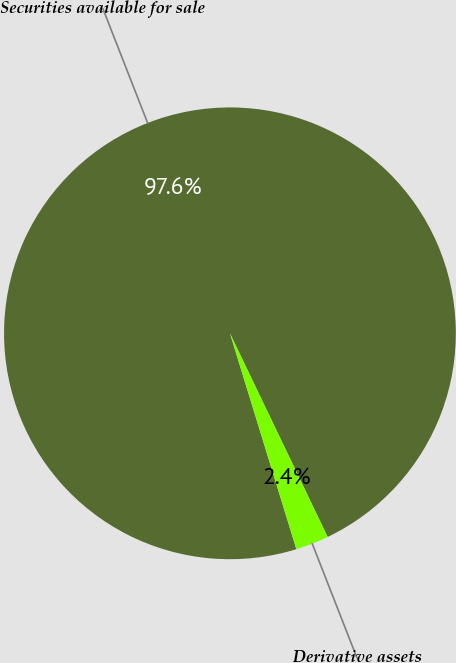Convert chart. <chart><loc_0><loc_0><loc_500><loc_500><pie_chart><fcel>Securities available for sale<fcel>Derivative assets<nl><fcel>97.63%<fcel>2.37%<nl></chart> 